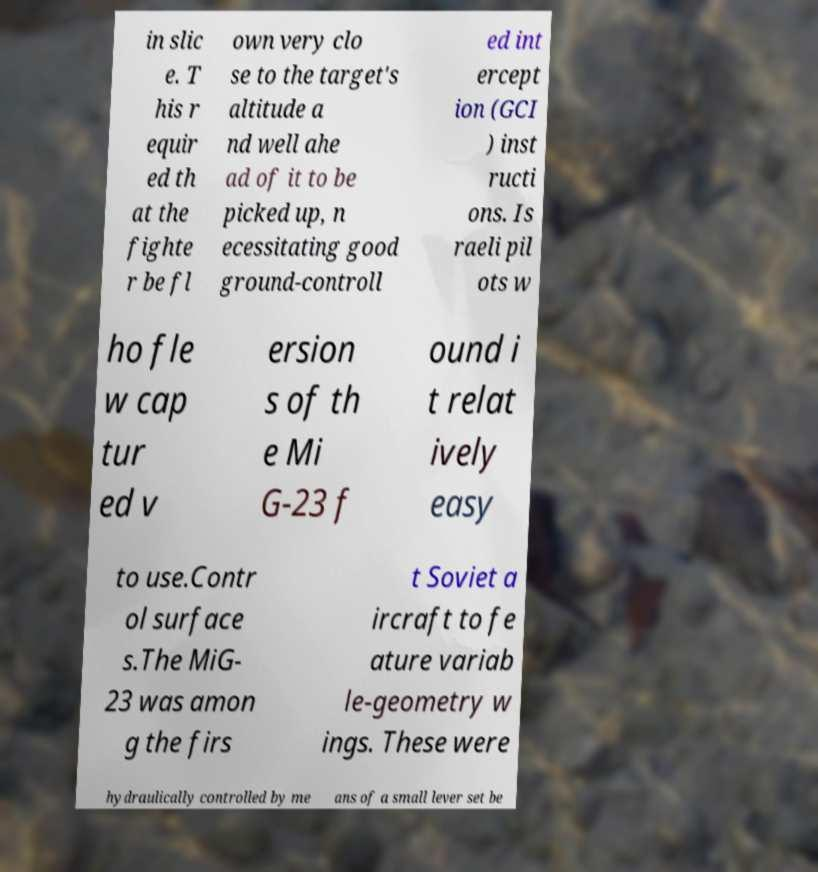Could you assist in decoding the text presented in this image and type it out clearly? in slic e. T his r equir ed th at the fighte r be fl own very clo se to the target's altitude a nd well ahe ad of it to be picked up, n ecessitating good ground-controll ed int ercept ion (GCI ) inst ructi ons. Is raeli pil ots w ho fle w cap tur ed v ersion s of th e Mi G-23 f ound i t relat ively easy to use.Contr ol surface s.The MiG- 23 was amon g the firs t Soviet a ircraft to fe ature variab le-geometry w ings. These were hydraulically controlled by me ans of a small lever set be 